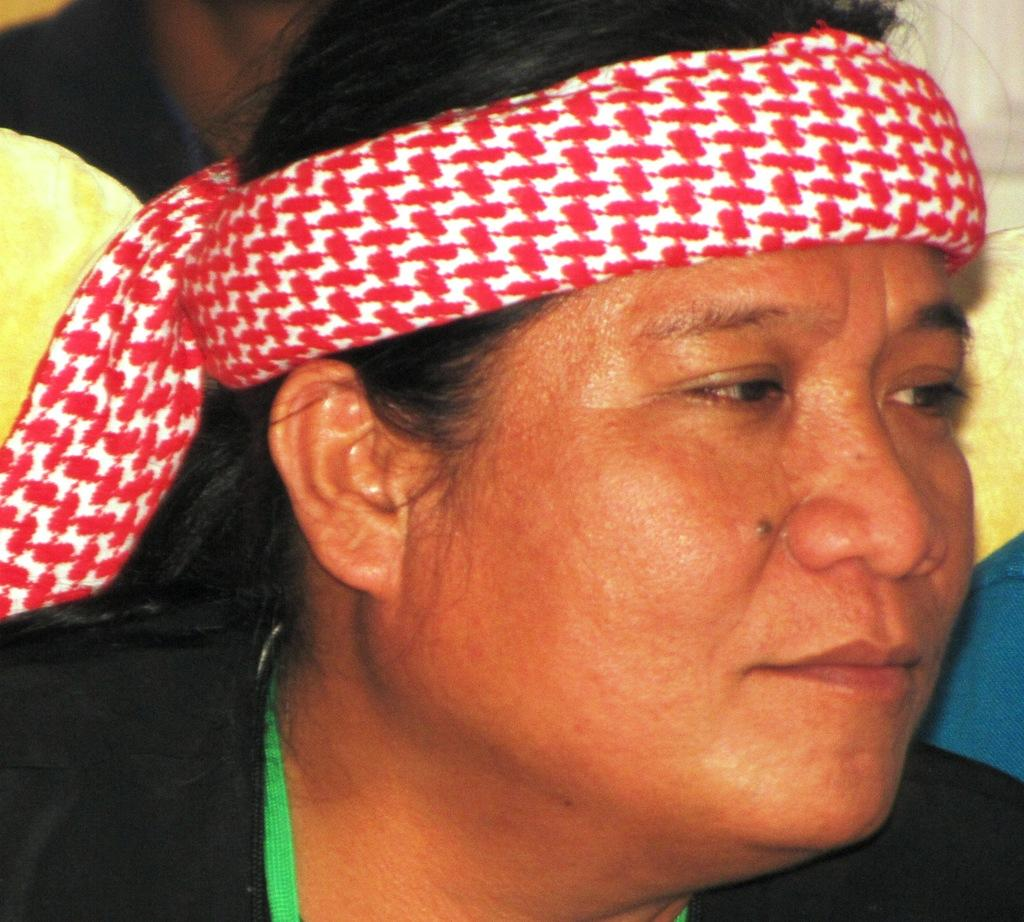What is present in the image? There is a woman in the image. What is the woman wearing? The woman is wearing clothes. What type of rake is the woman holding in the image? There is no rake present in the image. What position is the woman in while holding the rake? There is no rake or specific position mentioned in the image. 